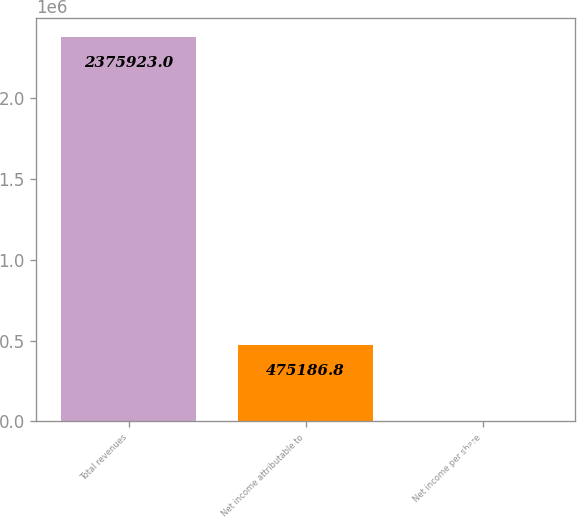Convert chart to OTSL. <chart><loc_0><loc_0><loc_500><loc_500><bar_chart><fcel>Total revenues<fcel>Net income attributable to<fcel>Net income per share<nl><fcel>2.37592e+06<fcel>475187<fcel>2.76<nl></chart> 